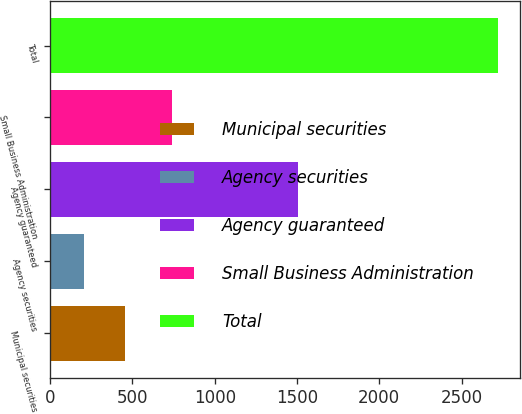Convert chart. <chart><loc_0><loc_0><loc_500><loc_500><bar_chart><fcel>Municipal securities<fcel>Agency securities<fcel>Agency guaranteed<fcel>Small Business Administration<fcel>Total<nl><fcel>455.8<fcel>204<fcel>1504<fcel>740<fcel>2722<nl></chart> 